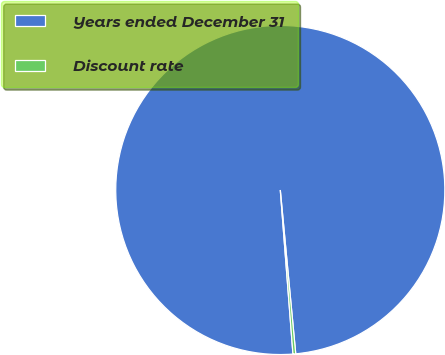Convert chart. <chart><loc_0><loc_0><loc_500><loc_500><pie_chart><fcel>Years ended December 31<fcel>Discount rate<nl><fcel>99.73%<fcel>0.27%<nl></chart> 